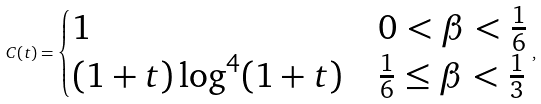<formula> <loc_0><loc_0><loc_500><loc_500>C ( t ) = \begin{cases} 1 & 0 < \beta < \frac { 1 } { 6 } \\ ( 1 + t ) \log ^ { 4 } ( 1 + t ) & \frac { 1 } { 6 } \leq \beta < \frac { 1 } { 3 } \end{cases} ,</formula> 